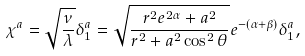<formula> <loc_0><loc_0><loc_500><loc_500>\chi ^ { a } = \sqrt { \frac { \nu } { \lambda } } \delta ^ { a } _ { 1 } = \sqrt { \frac { r ^ { 2 } e ^ { 2 \alpha } + a ^ { 2 } } { r ^ { 2 } + a ^ { 2 } \cos ^ { 2 } \theta } } e ^ { - ( \alpha + \beta ) } \delta ^ { a } _ { 1 } ,</formula> 